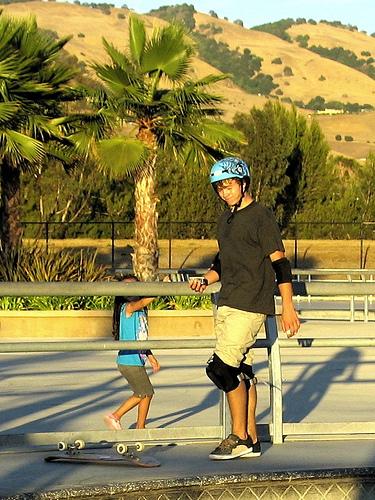What is he wearing on his head?
Quick response, please. Helmet. Who was riding the skateboard?
Short answer required. Man. Is this a tropical scene?
Short answer required. Yes. 